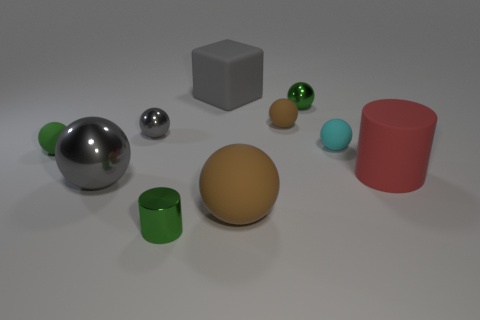Subtract all small balls. How many balls are left? 2 Subtract all purple blocks. How many gray balls are left? 2 Subtract all green balls. How many balls are left? 5 Subtract 2 spheres. How many spheres are left? 5 Subtract all balls. How many objects are left? 3 Add 8 large gray shiny balls. How many large gray shiny balls exist? 9 Subtract 1 green spheres. How many objects are left? 9 Subtract all purple cylinders. Subtract all green balls. How many cylinders are left? 2 Subtract all tiny spheres. Subtract all gray rubber objects. How many objects are left? 4 Add 9 big red rubber cylinders. How many big red rubber cylinders are left? 10 